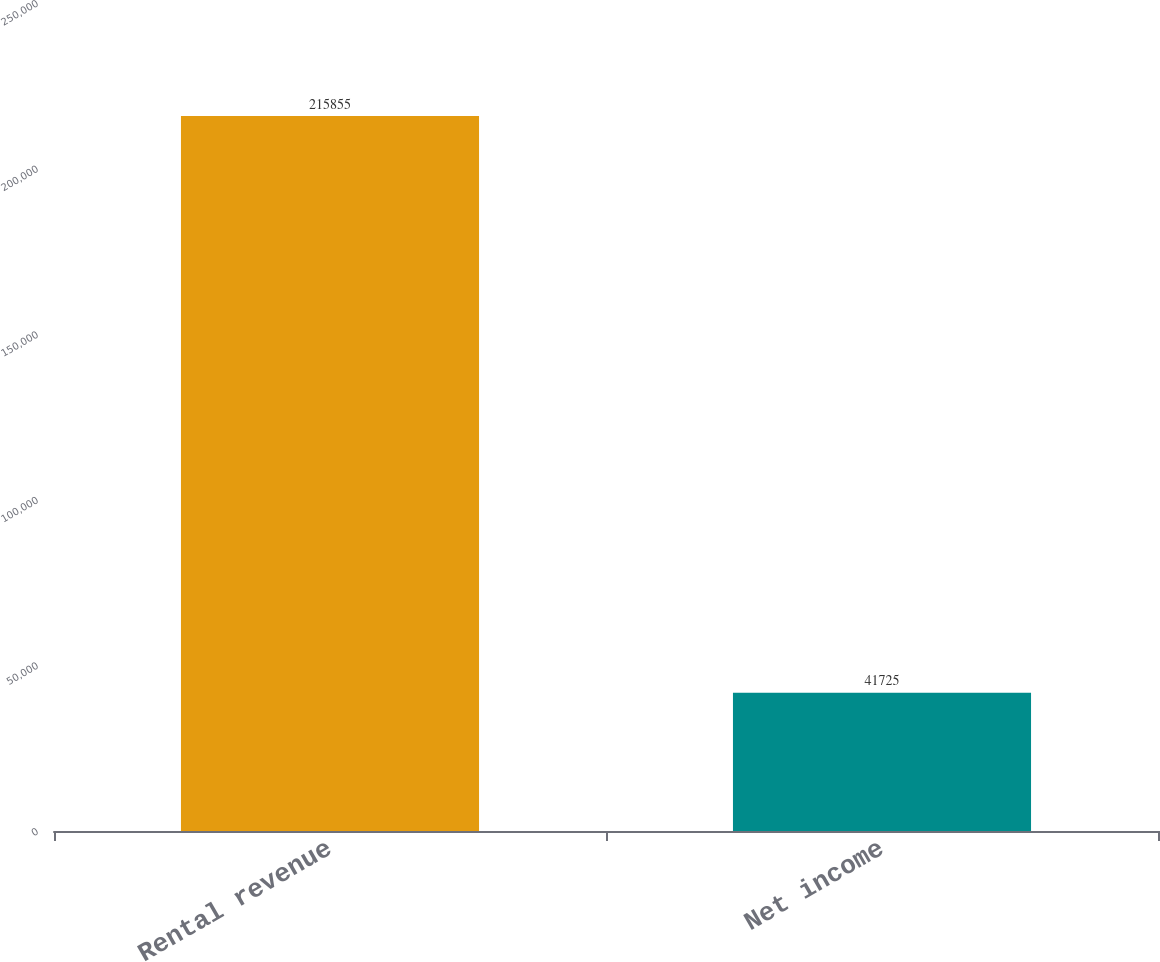Convert chart. <chart><loc_0><loc_0><loc_500><loc_500><bar_chart><fcel>Rental revenue<fcel>Net income<nl><fcel>215855<fcel>41725<nl></chart> 